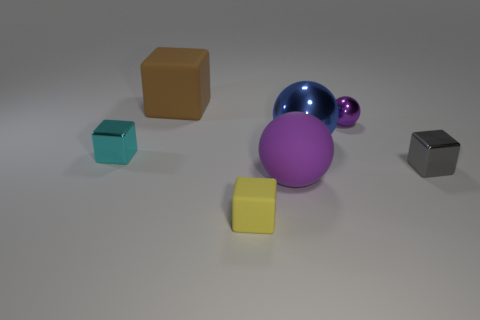Subtract all tiny purple metallic balls. How many balls are left? 2 Add 1 small purple shiny balls. How many objects exist? 8 Subtract all purple spheres. How many spheres are left? 1 Subtract all red cylinders. How many purple balls are left? 2 Subtract 3 spheres. How many spheres are left? 0 Subtract all spheres. How many objects are left? 4 Add 2 gray metallic blocks. How many gray metallic blocks are left? 3 Add 3 yellow rubber cylinders. How many yellow rubber cylinders exist? 3 Subtract 0 cyan spheres. How many objects are left? 7 Subtract all gray blocks. Subtract all purple cylinders. How many blocks are left? 3 